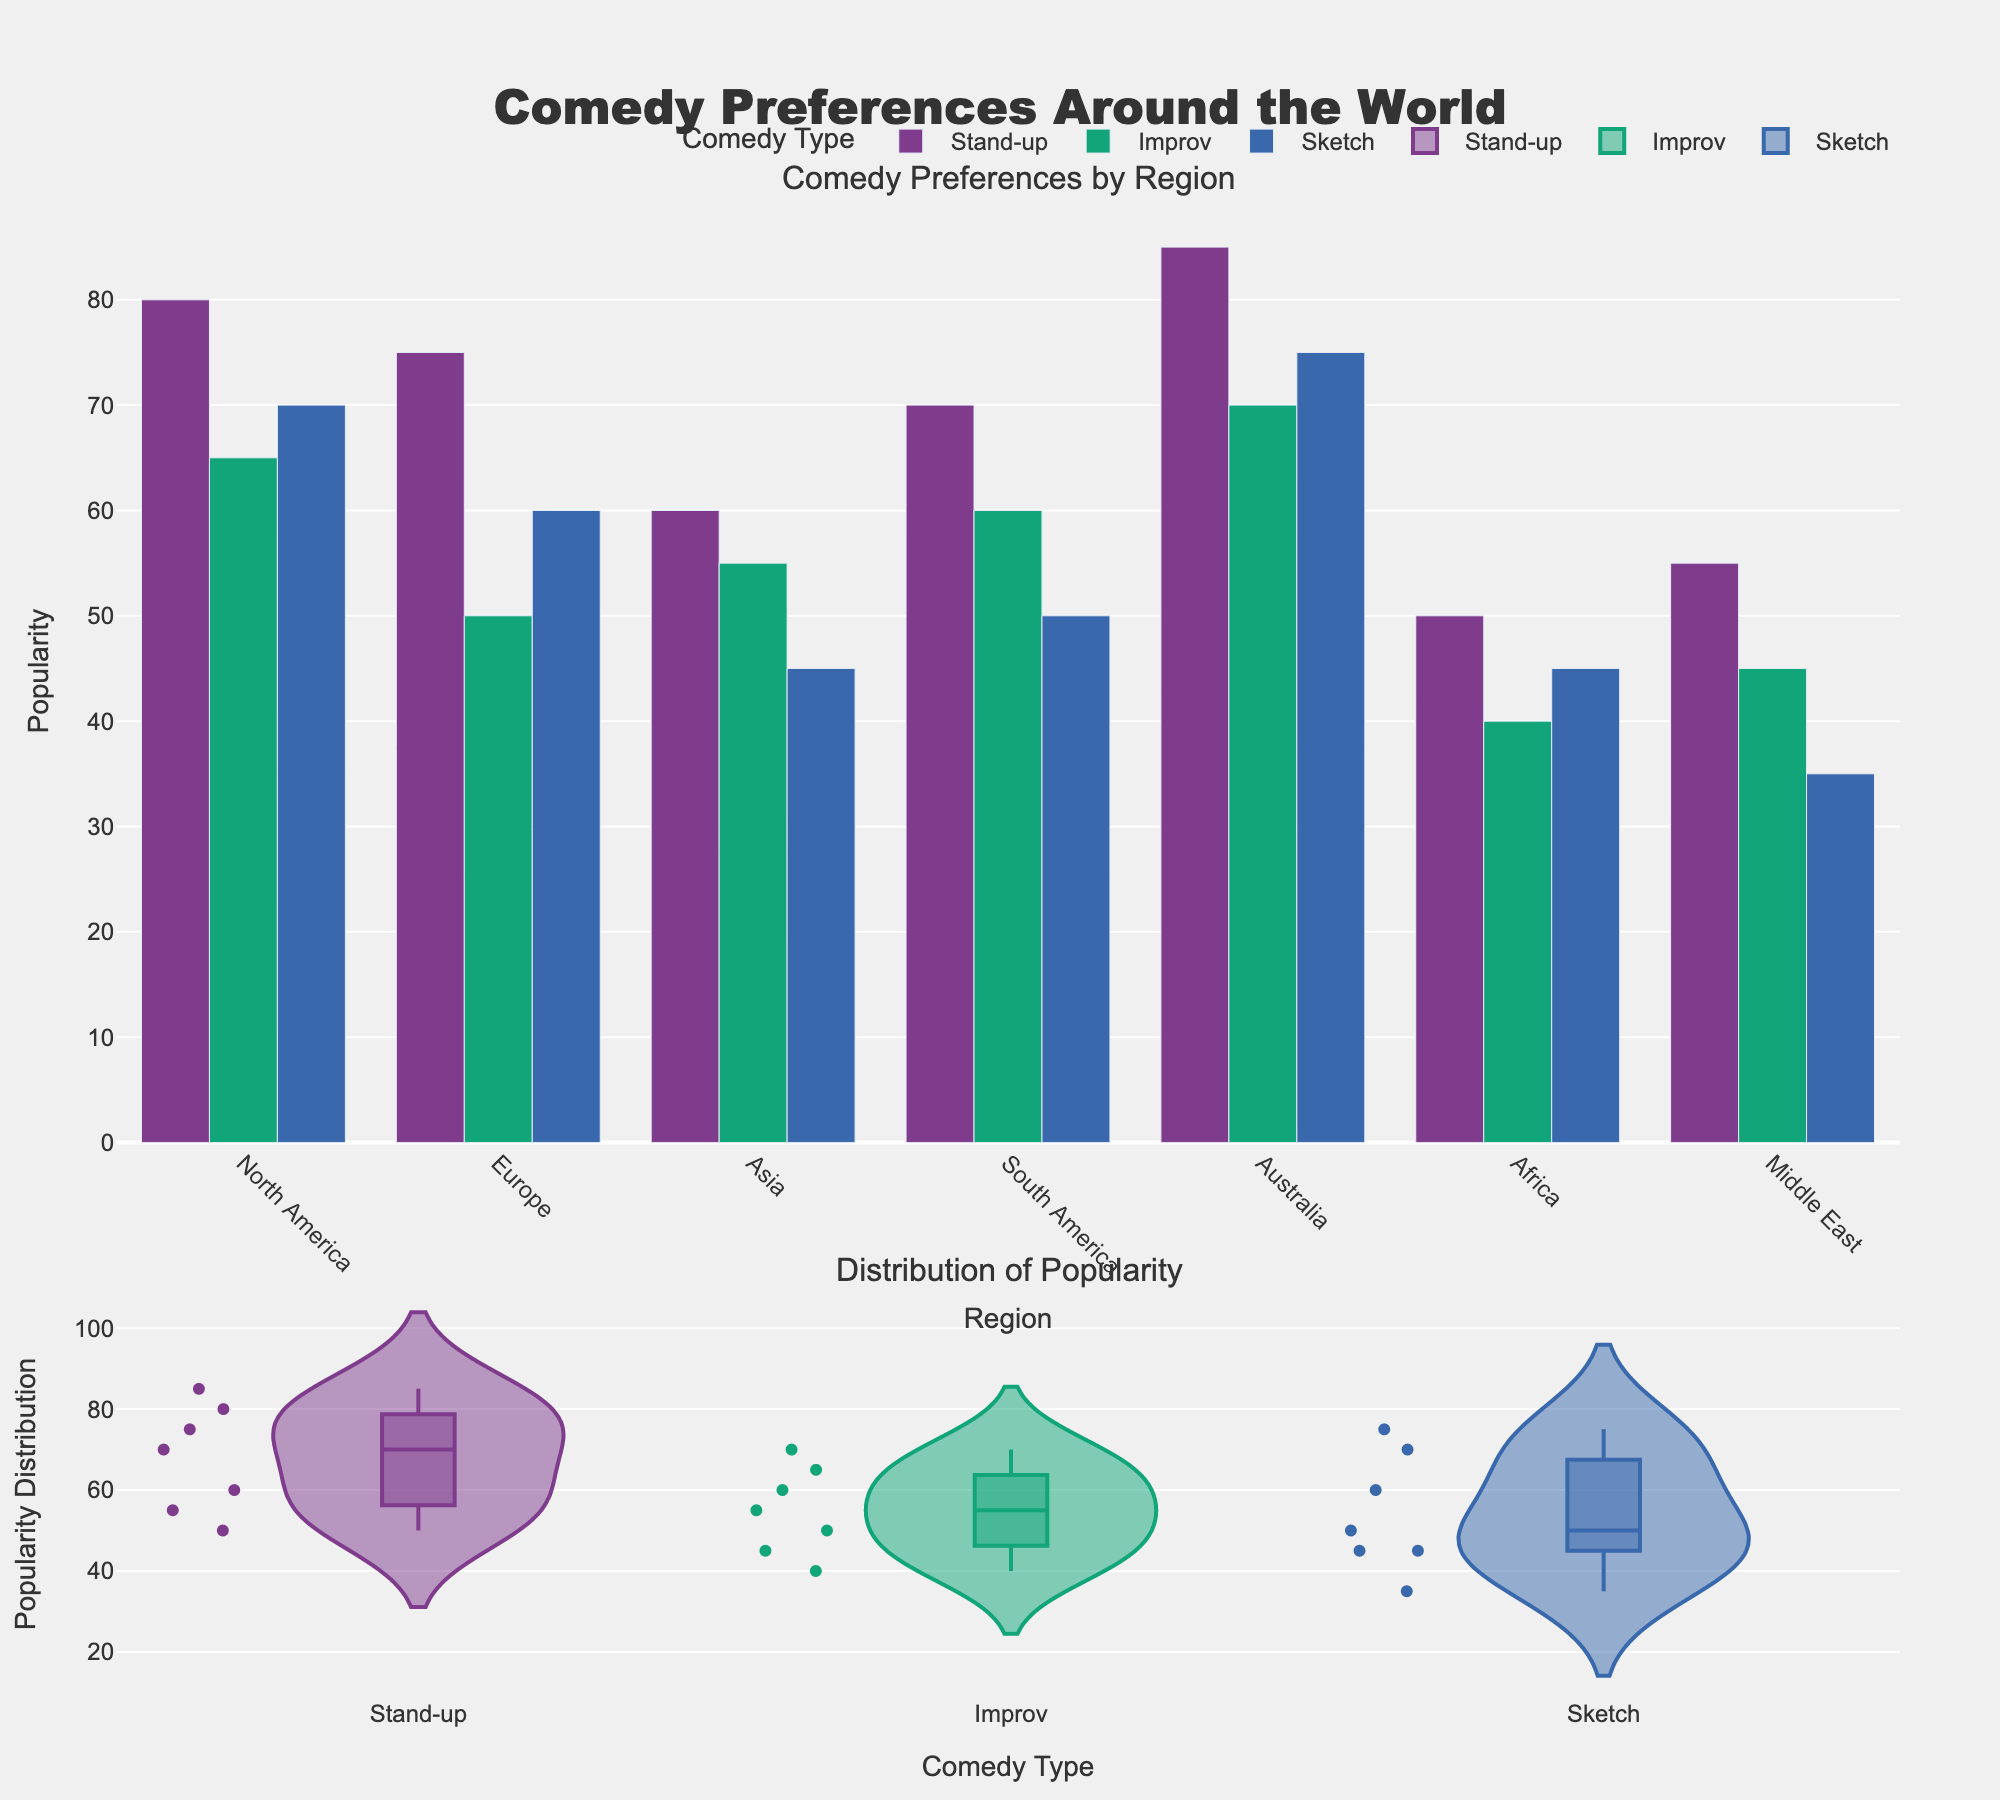What are the most preferred types of comedy in North America according to the plot? The bar chart shows the popularity of different types of comedy in each region. In North America, Stand-up has a higher bar compared to Improv and Sketch, indicating it is the most preferred type of comedy.
Answer: Stand-up Which region has the least popularity for Improv comedy? The bar chart section helps compare the popularity of Improv comedy across regions. Africa has the shortest bar for Improv comedy, indicating it has the least popularity there.
Answer: Africa What is the average popularity of Sketch comedy across all regions? We need to calculate the average popularity by summing the popularity values of Sketch comedy across all regions and dividing by the number of regions. The values are 70, 60, 45, 50, 75, 45, 35 which sum up to 380. There are 7 regions, so the average is 380/7 ≈ 54.29.
Answer: 54.29 Which region has the highest combined popularity for all types of comedy? To find the region with the highest combined popularity, sum the popularity values of all comedy types for each region and compare. North America has the highest combined popularity (80+65+70=215).
Answer: North America What's the difference in popularity between Stand-up and Sketch in Europe? From the bar chart, the popularity of Stand-up in Europe is 75 and Sketch is 60. Subtract Sketch's popularity from Stand-up's popularity: 75 - 60 = 15.
Answer: 15 How does the popularity distribution of Stand-up comedy vary? The violin plot shows the distribution of Stand-up comedy's popularity across different regions. The distribution is more spread out, with the popularity ranging from 50 to 85.
Answer: 50 to 85 Which type of comedy shows the least variation across different regions? By observing the width and spread of the violin plots, Improv comedy shows the least variation, as its distribution is more compact compared to Stand-up and Sketch.
Answer: Improv What is the second most popular type of comedy in Australia? The bar chart shows that in Australia, Sketch comedy has a higher bar than Improv but lower than Stand-up, making it the second most popular type there.
Answer: Sketch Which comedy type in Africa has the minimum popularity? From the bar chart, Improv has the shortest bar in Africa, indicating it has the minimum popularity among the comedy types in that region.
Answer: Improv Is there any region where Sketch is the most popular comedy type? By comparing the heights of the bars for Sketch with those of Stand-up and Improv across all regions, we see that Sketch is not the most popular comedy type in any region.
Answer: No 